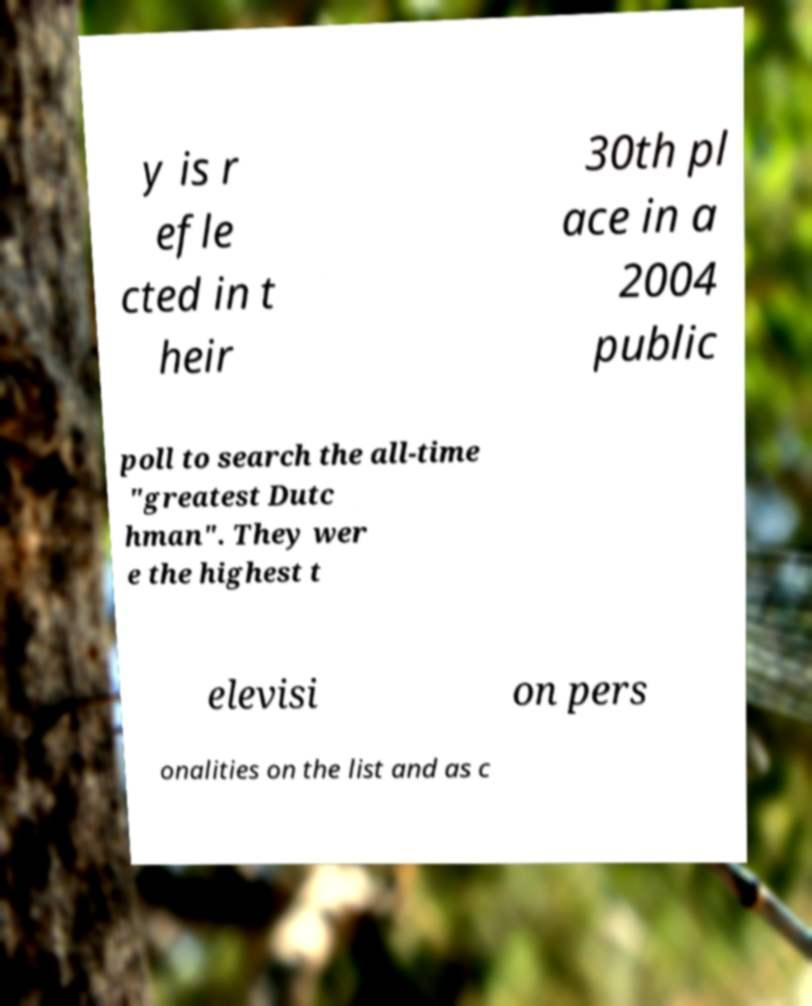I need the written content from this picture converted into text. Can you do that? y is r efle cted in t heir 30th pl ace in a 2004 public poll to search the all-time "greatest Dutc hman". They wer e the highest t elevisi on pers onalities on the list and as c 